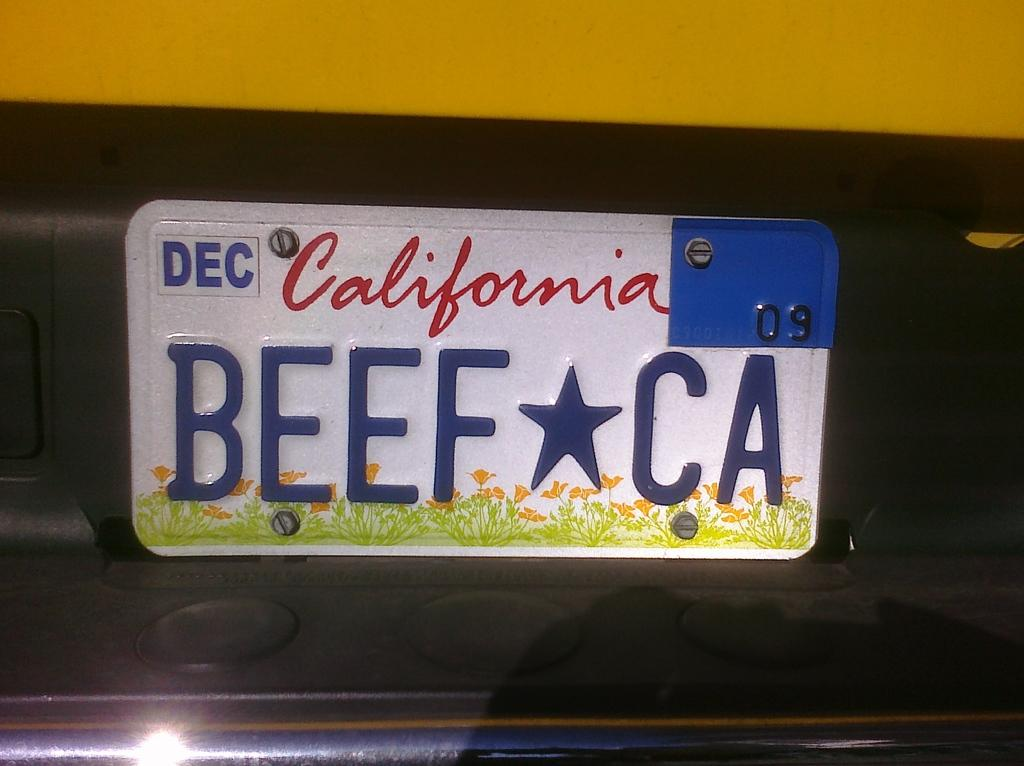What is the main subject of the image? The main subject of the image is a number plate. Can you describe the number plate in the image? The number plate is in the middle of the image and has text on it. What type of jar is being used as a prison for the agreement in the image? There is no jar, prison, or agreement present in the image; it only features a number plate with text on it. 